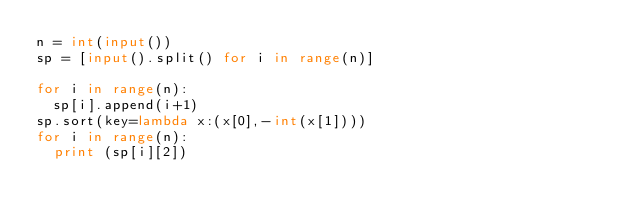<code> <loc_0><loc_0><loc_500><loc_500><_Python_>n = int(input())
sp = [input().split() for i in range(n)]

for i in range(n):
	sp[i].append(i+1)
sp.sort(key=lambda x:(x[0],-int(x[1])))
for i in range(n):
	print (sp[i][2])</code> 